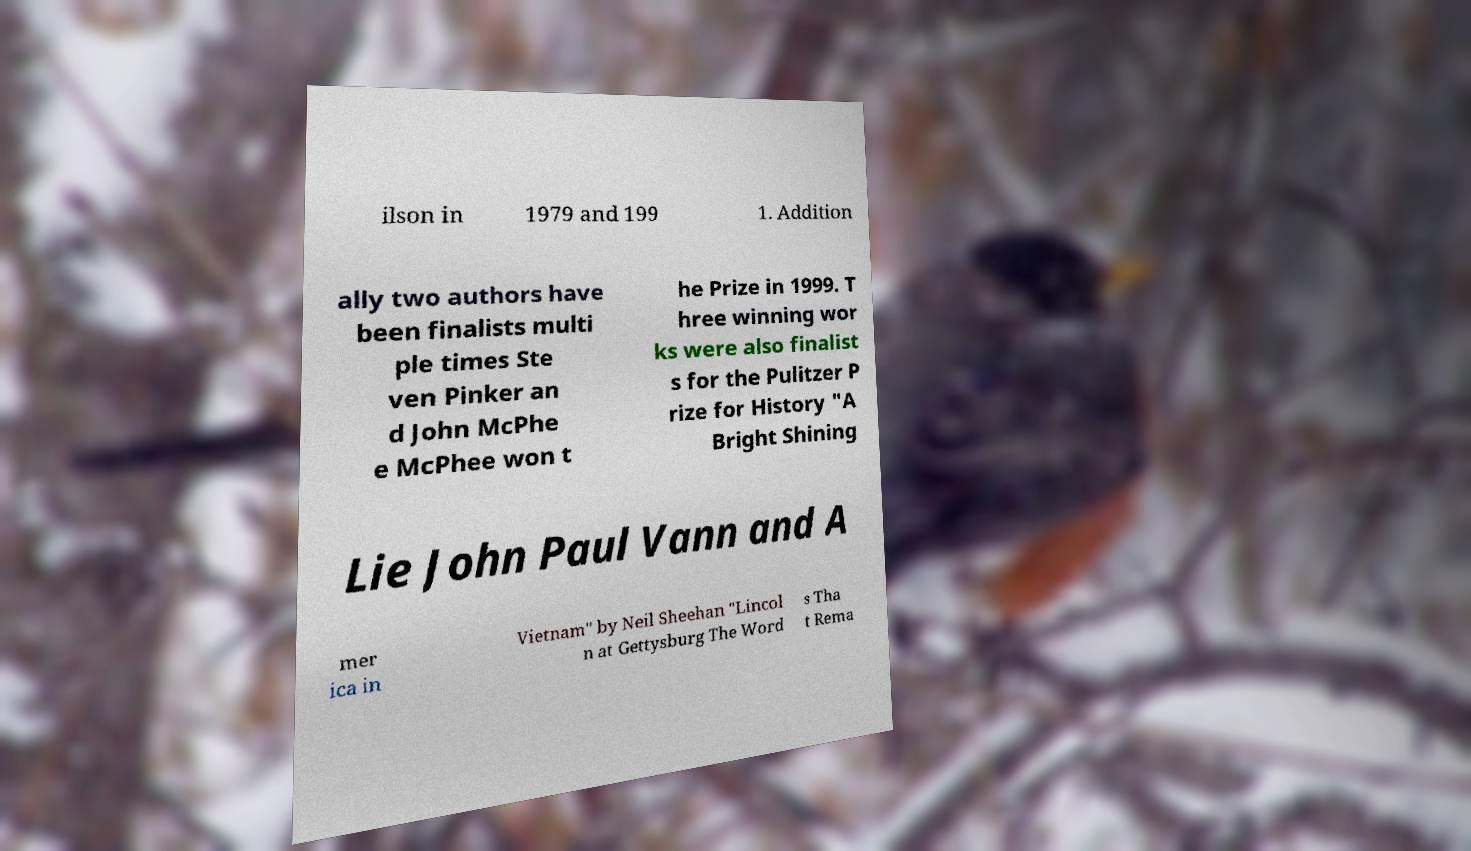Please read and relay the text visible in this image. What does it say? ilson in 1979 and 199 1. Addition ally two authors have been finalists multi ple times Ste ven Pinker an d John McPhe e McPhee won t he Prize in 1999. T hree winning wor ks were also finalist s for the Pulitzer P rize for History "A Bright Shining Lie John Paul Vann and A mer ica in Vietnam" by Neil Sheehan "Lincol n at Gettysburg The Word s Tha t Rema 